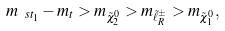Convert formula to latex. <formula><loc_0><loc_0><loc_500><loc_500>m _ { \ s t _ { 1 } } - m _ { t } > m _ { \tilde { \chi } ^ { 0 } _ { 2 } } > m _ { \tilde { \ell } ^ { \pm } _ { R } } > m _ { \tilde { \chi } ^ { 0 } _ { 1 } } , \\</formula> 